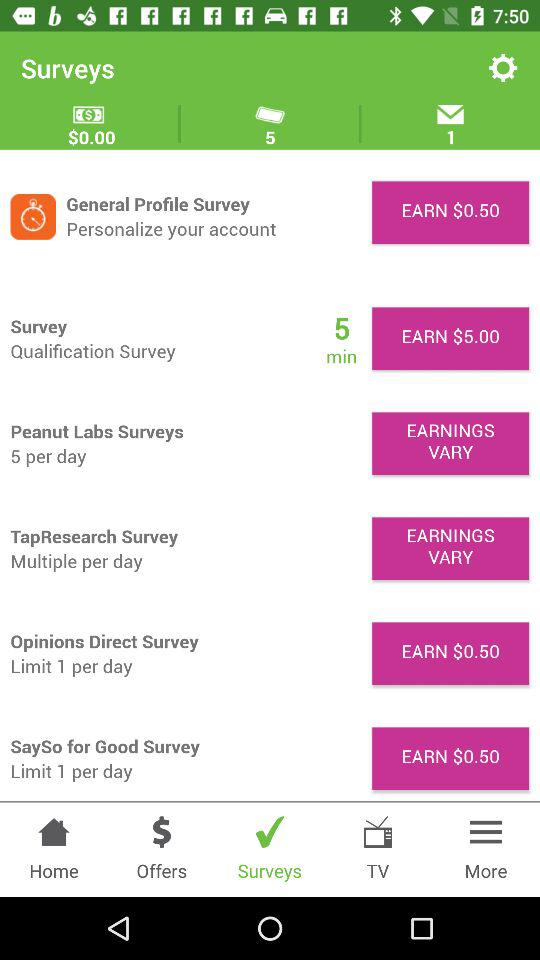Which tab is selected? The selected tab is "Surveys". 